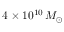<formula> <loc_0><loc_0><loc_500><loc_500>4 \times 1 0 ^ { 1 0 } \, M _ { \odot }</formula> 